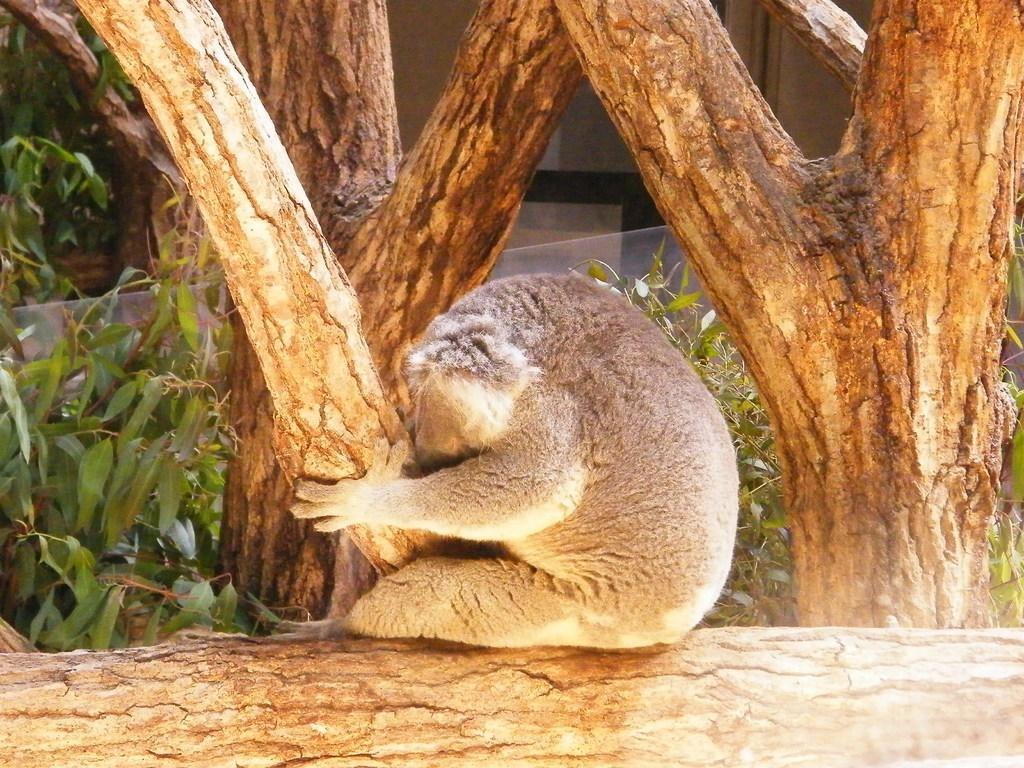What animal is present in the image? There is a monkey in the image. What is the monkey sitting on? The monkey is sitting on wood. What can be seen in the background of the image? There are trees and plants in the background of the image. Where is the store located in the image? There is no store present in the image. What type of meeting is taking place in the image? There is no meeting taking place in the image. 